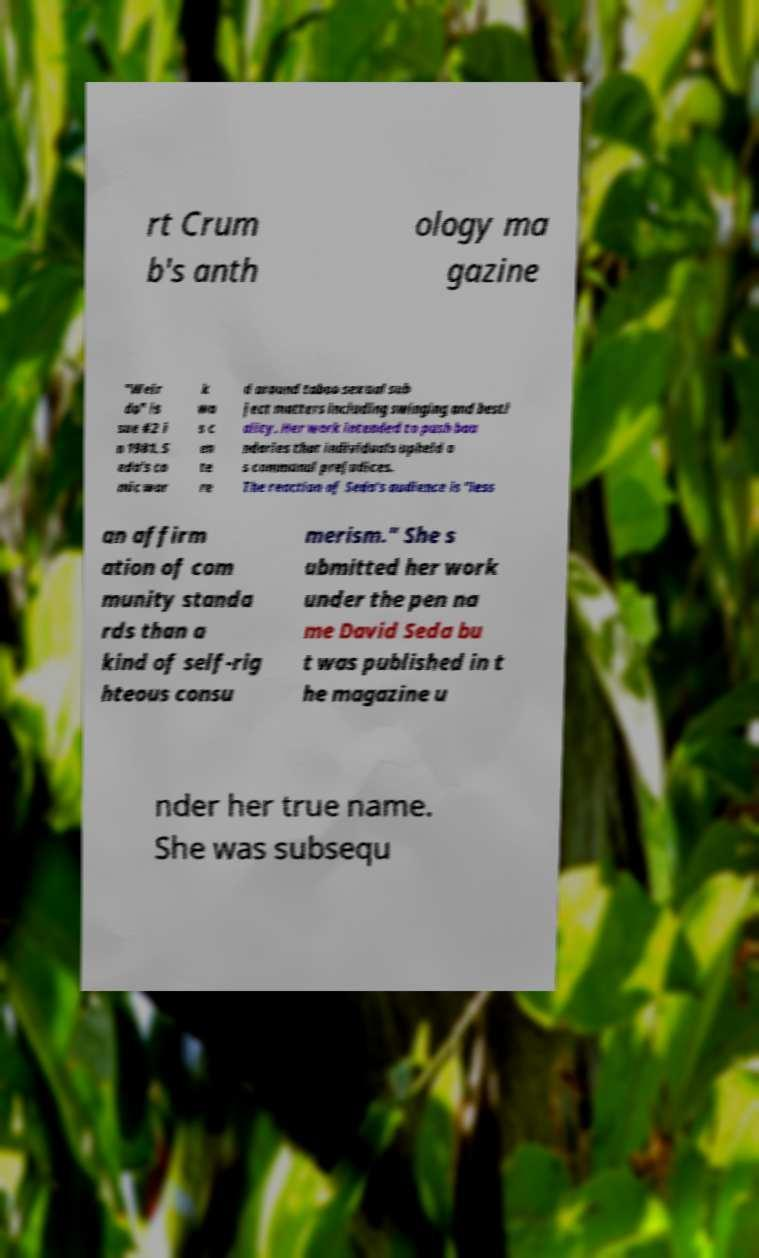Could you extract and type out the text from this image? rt Crum b's anth ology ma gazine "Weir do" is sue #2 i n 1981. S eda's co mic wor k wa s c en te re d around taboo sexual sub ject matters including swinging and besti ality. Her work intended to push bou ndaries that individuals upheld a s communal prejudices. The reaction of Seda's audience is "less an affirm ation of com munity standa rds than a kind of self-rig hteous consu merism." She s ubmitted her work under the pen na me David Seda bu t was published in t he magazine u nder her true name. She was subsequ 